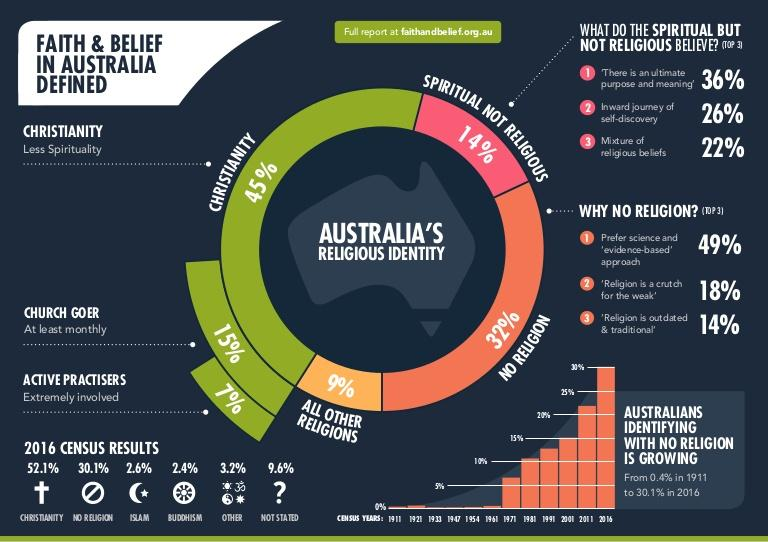Point out several critical features in this image. According to the 2016 census results in Australia, 3.2% of the population belongs to a religion other than their own. I believe in the inward journey of self-discovery, and while I am spiritual but not religious. According to the 2016 census results in Australia, only 2.4% of the population practices Buddhism. According to the 2016 census results in Australia, 9.6% of people did not state their religion. According to the 2016 census results in Australia, only 2.6% of the population practices Islam. 